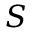<formula> <loc_0><loc_0><loc_500><loc_500>S</formula> 